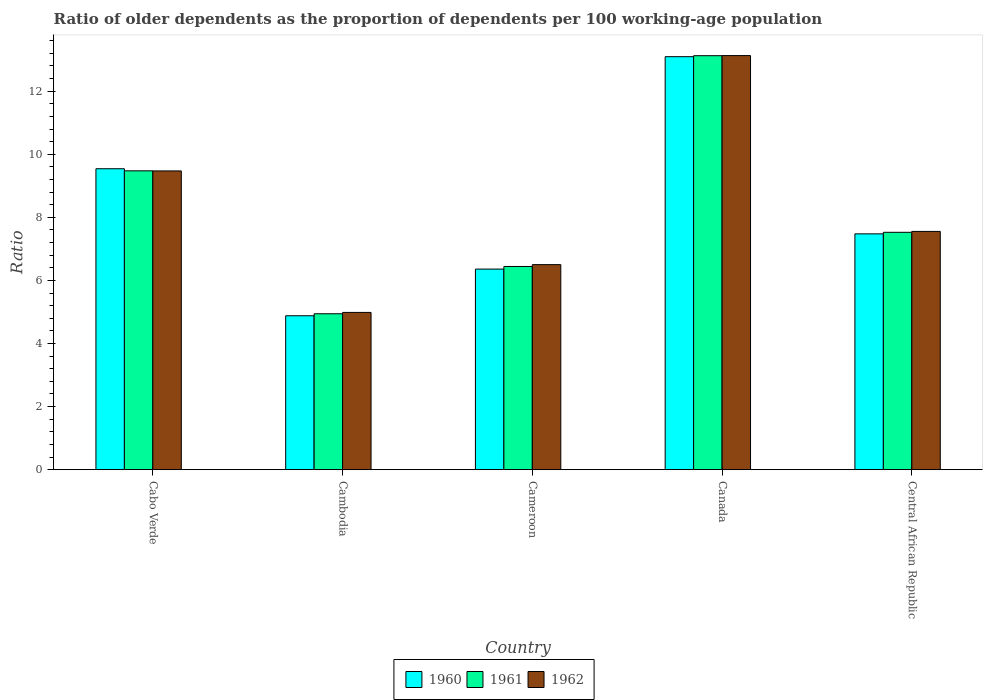How many groups of bars are there?
Offer a terse response. 5. Are the number of bars per tick equal to the number of legend labels?
Keep it short and to the point. Yes. How many bars are there on the 2nd tick from the left?
Your answer should be very brief. 3. How many bars are there on the 1st tick from the right?
Provide a succinct answer. 3. What is the label of the 5th group of bars from the left?
Provide a short and direct response. Central African Republic. What is the age dependency ratio(old) in 1961 in Canada?
Your response must be concise. 13.12. Across all countries, what is the maximum age dependency ratio(old) in 1962?
Make the answer very short. 13.13. Across all countries, what is the minimum age dependency ratio(old) in 1961?
Offer a terse response. 4.94. In which country was the age dependency ratio(old) in 1960 maximum?
Keep it short and to the point. Canada. In which country was the age dependency ratio(old) in 1961 minimum?
Your answer should be very brief. Cambodia. What is the total age dependency ratio(old) in 1962 in the graph?
Offer a terse response. 41.64. What is the difference between the age dependency ratio(old) in 1962 in Cabo Verde and that in Cambodia?
Your answer should be compact. 4.49. What is the difference between the age dependency ratio(old) in 1960 in Cambodia and the age dependency ratio(old) in 1961 in Cameroon?
Make the answer very short. -1.56. What is the average age dependency ratio(old) in 1960 per country?
Make the answer very short. 8.27. What is the difference between the age dependency ratio(old) of/in 1961 and age dependency ratio(old) of/in 1962 in Cameroon?
Keep it short and to the point. -0.06. In how many countries, is the age dependency ratio(old) in 1961 greater than 7.6?
Your response must be concise. 2. What is the ratio of the age dependency ratio(old) in 1960 in Cabo Verde to that in Canada?
Provide a short and direct response. 0.73. Is the difference between the age dependency ratio(old) in 1961 in Cambodia and Cameroon greater than the difference between the age dependency ratio(old) in 1962 in Cambodia and Cameroon?
Make the answer very short. Yes. What is the difference between the highest and the second highest age dependency ratio(old) in 1962?
Ensure brevity in your answer.  -3.66. What is the difference between the highest and the lowest age dependency ratio(old) in 1962?
Your answer should be very brief. 8.14. In how many countries, is the age dependency ratio(old) in 1961 greater than the average age dependency ratio(old) in 1961 taken over all countries?
Provide a succinct answer. 2. What does the 2nd bar from the right in Central African Republic represents?
Your answer should be compact. 1961. Is it the case that in every country, the sum of the age dependency ratio(old) in 1960 and age dependency ratio(old) in 1961 is greater than the age dependency ratio(old) in 1962?
Provide a short and direct response. Yes. How many bars are there?
Your answer should be compact. 15. Does the graph contain grids?
Provide a succinct answer. No. How many legend labels are there?
Provide a succinct answer. 3. How are the legend labels stacked?
Provide a short and direct response. Horizontal. What is the title of the graph?
Your answer should be compact. Ratio of older dependents as the proportion of dependents per 100 working-age population. What is the label or title of the Y-axis?
Ensure brevity in your answer.  Ratio. What is the Ratio in 1960 in Cabo Verde?
Keep it short and to the point. 9.54. What is the Ratio in 1961 in Cabo Verde?
Keep it short and to the point. 9.47. What is the Ratio of 1962 in Cabo Verde?
Make the answer very short. 9.47. What is the Ratio of 1960 in Cambodia?
Keep it short and to the point. 4.88. What is the Ratio of 1961 in Cambodia?
Offer a very short reply. 4.94. What is the Ratio of 1962 in Cambodia?
Make the answer very short. 4.99. What is the Ratio in 1960 in Cameroon?
Make the answer very short. 6.36. What is the Ratio of 1961 in Cameroon?
Provide a short and direct response. 6.44. What is the Ratio of 1962 in Cameroon?
Keep it short and to the point. 6.5. What is the Ratio of 1960 in Canada?
Ensure brevity in your answer.  13.09. What is the Ratio of 1961 in Canada?
Make the answer very short. 13.12. What is the Ratio in 1962 in Canada?
Give a very brief answer. 13.13. What is the Ratio of 1960 in Central African Republic?
Ensure brevity in your answer.  7.48. What is the Ratio in 1961 in Central African Republic?
Your response must be concise. 7.53. What is the Ratio in 1962 in Central African Republic?
Provide a short and direct response. 7.55. Across all countries, what is the maximum Ratio in 1960?
Your answer should be compact. 13.09. Across all countries, what is the maximum Ratio in 1961?
Give a very brief answer. 13.12. Across all countries, what is the maximum Ratio in 1962?
Give a very brief answer. 13.13. Across all countries, what is the minimum Ratio of 1960?
Provide a succinct answer. 4.88. Across all countries, what is the minimum Ratio of 1961?
Offer a terse response. 4.94. Across all countries, what is the minimum Ratio of 1962?
Your answer should be compact. 4.99. What is the total Ratio of 1960 in the graph?
Keep it short and to the point. 41.35. What is the total Ratio in 1961 in the graph?
Offer a very short reply. 41.51. What is the total Ratio of 1962 in the graph?
Make the answer very short. 41.64. What is the difference between the Ratio of 1960 in Cabo Verde and that in Cambodia?
Your answer should be very brief. 4.66. What is the difference between the Ratio of 1961 in Cabo Verde and that in Cambodia?
Your response must be concise. 4.53. What is the difference between the Ratio of 1962 in Cabo Verde and that in Cambodia?
Make the answer very short. 4.49. What is the difference between the Ratio in 1960 in Cabo Verde and that in Cameroon?
Your response must be concise. 3.18. What is the difference between the Ratio in 1961 in Cabo Verde and that in Cameroon?
Provide a short and direct response. 3.03. What is the difference between the Ratio in 1962 in Cabo Verde and that in Cameroon?
Provide a succinct answer. 2.97. What is the difference between the Ratio of 1960 in Cabo Verde and that in Canada?
Provide a succinct answer. -3.55. What is the difference between the Ratio of 1961 in Cabo Verde and that in Canada?
Your answer should be very brief. -3.65. What is the difference between the Ratio in 1962 in Cabo Verde and that in Canada?
Your answer should be very brief. -3.66. What is the difference between the Ratio in 1960 in Cabo Verde and that in Central African Republic?
Your answer should be very brief. 2.06. What is the difference between the Ratio in 1961 in Cabo Verde and that in Central African Republic?
Ensure brevity in your answer.  1.95. What is the difference between the Ratio of 1962 in Cabo Verde and that in Central African Republic?
Your response must be concise. 1.92. What is the difference between the Ratio in 1960 in Cambodia and that in Cameroon?
Offer a very short reply. -1.48. What is the difference between the Ratio of 1961 in Cambodia and that in Cameroon?
Offer a very short reply. -1.5. What is the difference between the Ratio in 1962 in Cambodia and that in Cameroon?
Offer a very short reply. -1.51. What is the difference between the Ratio of 1960 in Cambodia and that in Canada?
Provide a succinct answer. -8.21. What is the difference between the Ratio of 1961 in Cambodia and that in Canada?
Keep it short and to the point. -8.18. What is the difference between the Ratio of 1962 in Cambodia and that in Canada?
Your answer should be compact. -8.14. What is the difference between the Ratio in 1960 in Cambodia and that in Central African Republic?
Provide a short and direct response. -2.6. What is the difference between the Ratio of 1961 in Cambodia and that in Central African Republic?
Offer a terse response. -2.58. What is the difference between the Ratio in 1962 in Cambodia and that in Central African Republic?
Offer a very short reply. -2.57. What is the difference between the Ratio of 1960 in Cameroon and that in Canada?
Keep it short and to the point. -6.73. What is the difference between the Ratio of 1961 in Cameroon and that in Canada?
Your response must be concise. -6.68. What is the difference between the Ratio in 1962 in Cameroon and that in Canada?
Offer a very short reply. -6.63. What is the difference between the Ratio of 1960 in Cameroon and that in Central African Republic?
Your answer should be very brief. -1.12. What is the difference between the Ratio of 1961 in Cameroon and that in Central African Republic?
Make the answer very short. -1.08. What is the difference between the Ratio of 1962 in Cameroon and that in Central African Republic?
Provide a short and direct response. -1.05. What is the difference between the Ratio in 1960 in Canada and that in Central African Republic?
Provide a succinct answer. 5.62. What is the difference between the Ratio in 1961 in Canada and that in Central African Republic?
Provide a short and direct response. 5.6. What is the difference between the Ratio of 1962 in Canada and that in Central African Republic?
Ensure brevity in your answer.  5.57. What is the difference between the Ratio in 1960 in Cabo Verde and the Ratio in 1961 in Cambodia?
Your answer should be compact. 4.6. What is the difference between the Ratio in 1960 in Cabo Verde and the Ratio in 1962 in Cambodia?
Ensure brevity in your answer.  4.55. What is the difference between the Ratio in 1961 in Cabo Verde and the Ratio in 1962 in Cambodia?
Your answer should be very brief. 4.49. What is the difference between the Ratio in 1960 in Cabo Verde and the Ratio in 1961 in Cameroon?
Your answer should be compact. 3.1. What is the difference between the Ratio in 1960 in Cabo Verde and the Ratio in 1962 in Cameroon?
Make the answer very short. 3.04. What is the difference between the Ratio of 1961 in Cabo Verde and the Ratio of 1962 in Cameroon?
Provide a succinct answer. 2.97. What is the difference between the Ratio in 1960 in Cabo Verde and the Ratio in 1961 in Canada?
Provide a succinct answer. -3.58. What is the difference between the Ratio of 1960 in Cabo Verde and the Ratio of 1962 in Canada?
Your answer should be very brief. -3.59. What is the difference between the Ratio in 1961 in Cabo Verde and the Ratio in 1962 in Canada?
Give a very brief answer. -3.65. What is the difference between the Ratio of 1960 in Cabo Verde and the Ratio of 1961 in Central African Republic?
Provide a succinct answer. 2.01. What is the difference between the Ratio of 1960 in Cabo Verde and the Ratio of 1962 in Central African Republic?
Offer a terse response. 1.99. What is the difference between the Ratio of 1961 in Cabo Verde and the Ratio of 1962 in Central African Republic?
Offer a very short reply. 1.92. What is the difference between the Ratio of 1960 in Cambodia and the Ratio of 1961 in Cameroon?
Keep it short and to the point. -1.56. What is the difference between the Ratio in 1960 in Cambodia and the Ratio in 1962 in Cameroon?
Your answer should be very brief. -1.62. What is the difference between the Ratio in 1961 in Cambodia and the Ratio in 1962 in Cameroon?
Offer a terse response. -1.56. What is the difference between the Ratio in 1960 in Cambodia and the Ratio in 1961 in Canada?
Give a very brief answer. -8.24. What is the difference between the Ratio of 1960 in Cambodia and the Ratio of 1962 in Canada?
Offer a very short reply. -8.25. What is the difference between the Ratio in 1961 in Cambodia and the Ratio in 1962 in Canada?
Provide a short and direct response. -8.18. What is the difference between the Ratio in 1960 in Cambodia and the Ratio in 1961 in Central African Republic?
Provide a succinct answer. -2.65. What is the difference between the Ratio in 1960 in Cambodia and the Ratio in 1962 in Central African Republic?
Your answer should be very brief. -2.67. What is the difference between the Ratio of 1961 in Cambodia and the Ratio of 1962 in Central African Republic?
Make the answer very short. -2.61. What is the difference between the Ratio of 1960 in Cameroon and the Ratio of 1961 in Canada?
Keep it short and to the point. -6.76. What is the difference between the Ratio in 1960 in Cameroon and the Ratio in 1962 in Canada?
Your response must be concise. -6.77. What is the difference between the Ratio of 1961 in Cameroon and the Ratio of 1962 in Canada?
Your answer should be compact. -6.69. What is the difference between the Ratio of 1960 in Cameroon and the Ratio of 1961 in Central African Republic?
Ensure brevity in your answer.  -1.17. What is the difference between the Ratio of 1960 in Cameroon and the Ratio of 1962 in Central African Republic?
Give a very brief answer. -1.19. What is the difference between the Ratio of 1961 in Cameroon and the Ratio of 1962 in Central African Republic?
Your response must be concise. -1.11. What is the difference between the Ratio of 1960 in Canada and the Ratio of 1961 in Central African Republic?
Provide a short and direct response. 5.57. What is the difference between the Ratio of 1960 in Canada and the Ratio of 1962 in Central African Republic?
Make the answer very short. 5.54. What is the difference between the Ratio in 1961 in Canada and the Ratio in 1962 in Central African Republic?
Your answer should be very brief. 5.57. What is the average Ratio of 1960 per country?
Make the answer very short. 8.27. What is the average Ratio in 1961 per country?
Provide a succinct answer. 8.3. What is the average Ratio in 1962 per country?
Your answer should be very brief. 8.33. What is the difference between the Ratio of 1960 and Ratio of 1961 in Cabo Verde?
Give a very brief answer. 0.07. What is the difference between the Ratio in 1960 and Ratio in 1962 in Cabo Verde?
Keep it short and to the point. 0.07. What is the difference between the Ratio in 1961 and Ratio in 1962 in Cabo Verde?
Provide a short and direct response. 0. What is the difference between the Ratio of 1960 and Ratio of 1961 in Cambodia?
Your answer should be very brief. -0.06. What is the difference between the Ratio of 1960 and Ratio of 1962 in Cambodia?
Ensure brevity in your answer.  -0.11. What is the difference between the Ratio in 1961 and Ratio in 1962 in Cambodia?
Provide a short and direct response. -0.04. What is the difference between the Ratio in 1960 and Ratio in 1961 in Cameroon?
Your response must be concise. -0.08. What is the difference between the Ratio of 1960 and Ratio of 1962 in Cameroon?
Offer a very short reply. -0.14. What is the difference between the Ratio in 1961 and Ratio in 1962 in Cameroon?
Keep it short and to the point. -0.06. What is the difference between the Ratio in 1960 and Ratio in 1961 in Canada?
Your answer should be compact. -0.03. What is the difference between the Ratio in 1960 and Ratio in 1962 in Canada?
Offer a very short reply. -0.03. What is the difference between the Ratio of 1961 and Ratio of 1962 in Canada?
Provide a succinct answer. -0. What is the difference between the Ratio of 1960 and Ratio of 1961 in Central African Republic?
Give a very brief answer. -0.05. What is the difference between the Ratio in 1960 and Ratio in 1962 in Central African Republic?
Provide a short and direct response. -0.08. What is the difference between the Ratio of 1961 and Ratio of 1962 in Central African Republic?
Keep it short and to the point. -0.03. What is the ratio of the Ratio in 1960 in Cabo Verde to that in Cambodia?
Offer a terse response. 1.95. What is the ratio of the Ratio of 1961 in Cabo Verde to that in Cambodia?
Your response must be concise. 1.92. What is the ratio of the Ratio in 1962 in Cabo Verde to that in Cambodia?
Offer a very short reply. 1.9. What is the ratio of the Ratio in 1960 in Cabo Verde to that in Cameroon?
Ensure brevity in your answer.  1.5. What is the ratio of the Ratio of 1961 in Cabo Verde to that in Cameroon?
Make the answer very short. 1.47. What is the ratio of the Ratio in 1962 in Cabo Verde to that in Cameroon?
Make the answer very short. 1.46. What is the ratio of the Ratio in 1960 in Cabo Verde to that in Canada?
Provide a succinct answer. 0.73. What is the ratio of the Ratio of 1961 in Cabo Verde to that in Canada?
Offer a very short reply. 0.72. What is the ratio of the Ratio in 1962 in Cabo Verde to that in Canada?
Your answer should be very brief. 0.72. What is the ratio of the Ratio of 1960 in Cabo Verde to that in Central African Republic?
Make the answer very short. 1.28. What is the ratio of the Ratio in 1961 in Cabo Verde to that in Central African Republic?
Your response must be concise. 1.26. What is the ratio of the Ratio of 1962 in Cabo Verde to that in Central African Republic?
Give a very brief answer. 1.25. What is the ratio of the Ratio of 1960 in Cambodia to that in Cameroon?
Provide a short and direct response. 0.77. What is the ratio of the Ratio of 1961 in Cambodia to that in Cameroon?
Offer a terse response. 0.77. What is the ratio of the Ratio in 1962 in Cambodia to that in Cameroon?
Your answer should be compact. 0.77. What is the ratio of the Ratio in 1960 in Cambodia to that in Canada?
Provide a succinct answer. 0.37. What is the ratio of the Ratio in 1961 in Cambodia to that in Canada?
Keep it short and to the point. 0.38. What is the ratio of the Ratio of 1962 in Cambodia to that in Canada?
Provide a short and direct response. 0.38. What is the ratio of the Ratio in 1960 in Cambodia to that in Central African Republic?
Make the answer very short. 0.65. What is the ratio of the Ratio in 1961 in Cambodia to that in Central African Republic?
Ensure brevity in your answer.  0.66. What is the ratio of the Ratio in 1962 in Cambodia to that in Central African Republic?
Your answer should be compact. 0.66. What is the ratio of the Ratio in 1960 in Cameroon to that in Canada?
Offer a very short reply. 0.49. What is the ratio of the Ratio in 1961 in Cameroon to that in Canada?
Provide a succinct answer. 0.49. What is the ratio of the Ratio in 1962 in Cameroon to that in Canada?
Ensure brevity in your answer.  0.5. What is the ratio of the Ratio of 1960 in Cameroon to that in Central African Republic?
Ensure brevity in your answer.  0.85. What is the ratio of the Ratio in 1961 in Cameroon to that in Central African Republic?
Your response must be concise. 0.86. What is the ratio of the Ratio in 1962 in Cameroon to that in Central African Republic?
Offer a very short reply. 0.86. What is the ratio of the Ratio of 1960 in Canada to that in Central African Republic?
Offer a very short reply. 1.75. What is the ratio of the Ratio of 1961 in Canada to that in Central African Republic?
Offer a terse response. 1.74. What is the ratio of the Ratio of 1962 in Canada to that in Central African Republic?
Keep it short and to the point. 1.74. What is the difference between the highest and the second highest Ratio in 1960?
Provide a succinct answer. 3.55. What is the difference between the highest and the second highest Ratio in 1961?
Provide a succinct answer. 3.65. What is the difference between the highest and the second highest Ratio in 1962?
Give a very brief answer. 3.66. What is the difference between the highest and the lowest Ratio of 1960?
Provide a succinct answer. 8.21. What is the difference between the highest and the lowest Ratio of 1961?
Keep it short and to the point. 8.18. What is the difference between the highest and the lowest Ratio of 1962?
Offer a terse response. 8.14. 